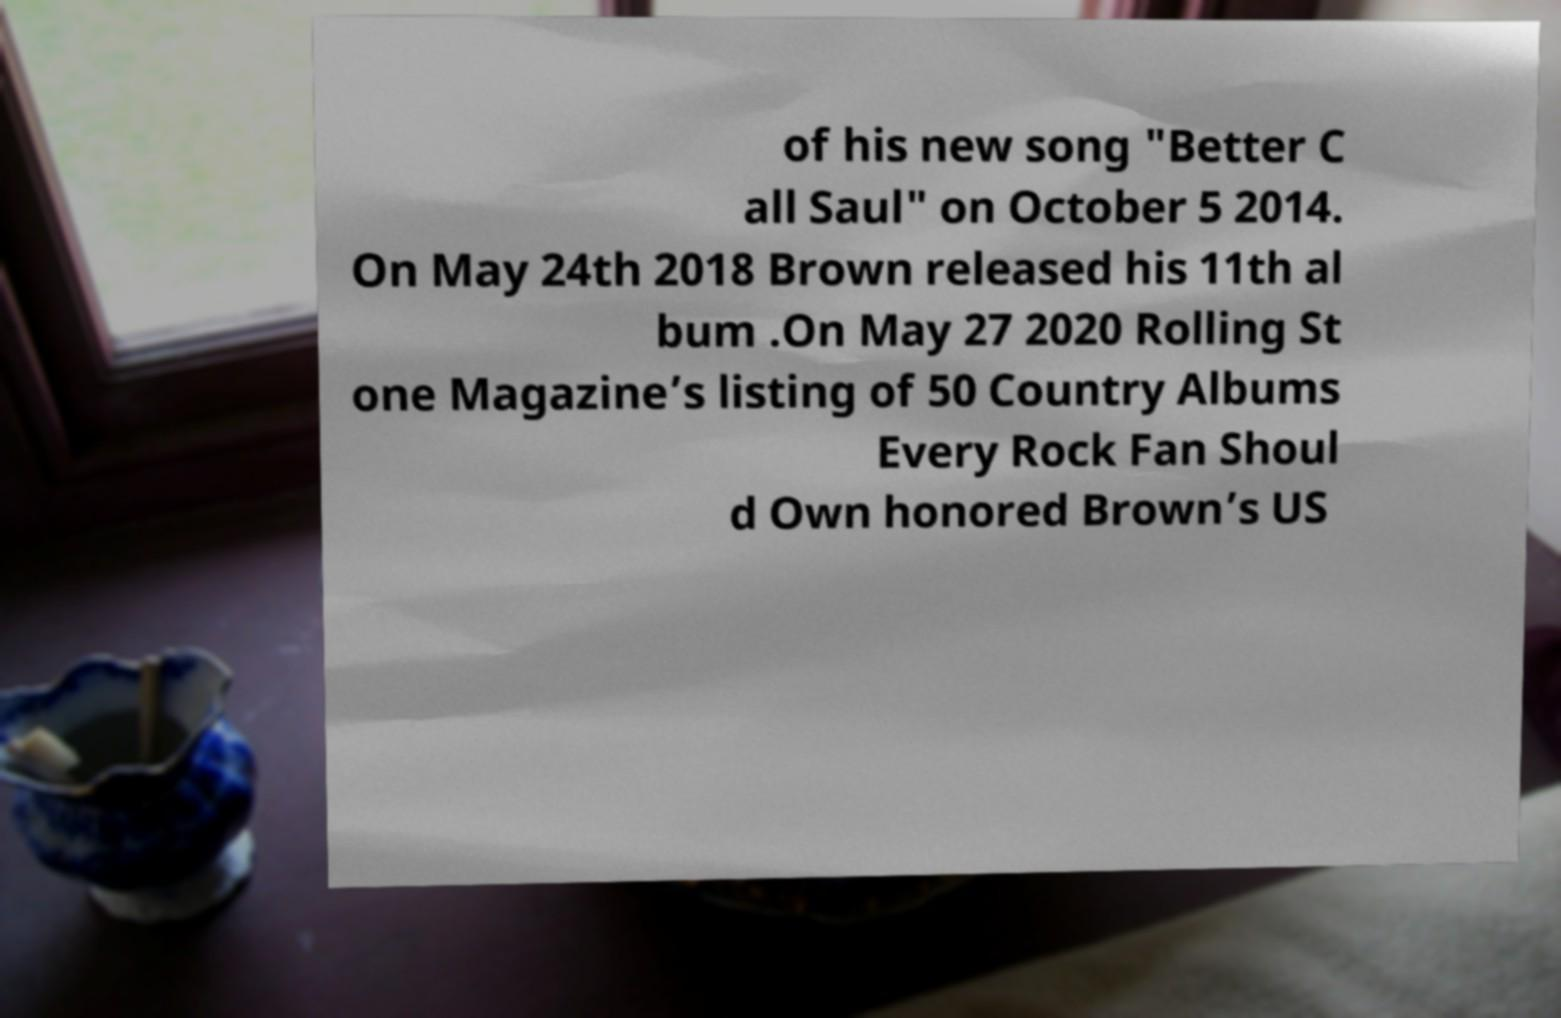For documentation purposes, I need the text within this image transcribed. Could you provide that? of his new song "Better C all Saul" on October 5 2014. On May 24th 2018 Brown released his 11th al bum .On May 27 2020 Rolling St one Magazine’s listing of 50 Country Albums Every Rock Fan Shoul d Own honored Brown’s US 